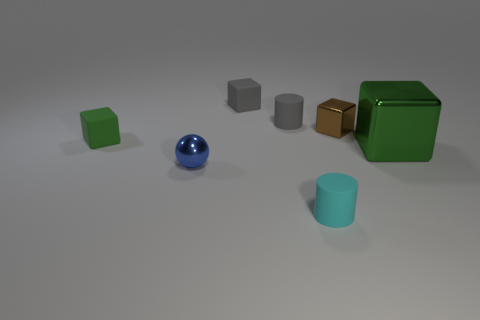There is another rubber object that is the same color as the large thing; what is its size?
Offer a terse response. Small. What number of things are objects that are left of the large thing or small cylinders that are in front of the tiny blue ball?
Make the answer very short. 6. Is there any other thing of the same color as the large metal cube?
Keep it short and to the point. Yes. Is the number of gray cubes that are right of the gray rubber cylinder the same as the number of gray things that are in front of the tiny green cube?
Offer a very short reply. Yes. Is the number of small cylinders on the right side of the big metallic cube greater than the number of tiny blocks?
Offer a terse response. No. How many things are small gray rubber objects on the right side of the small gray matte cube or tiny gray matte cylinders?
Your answer should be compact. 1. What number of tiny cyan things are made of the same material as the big cube?
Your answer should be compact. 0. There is another rubber object that is the same color as the large thing; what is its shape?
Provide a succinct answer. Cube. Is there another matte object of the same shape as the small cyan matte object?
Provide a short and direct response. Yes. What is the shape of the brown thing that is the same size as the metallic sphere?
Give a very brief answer. Cube. 